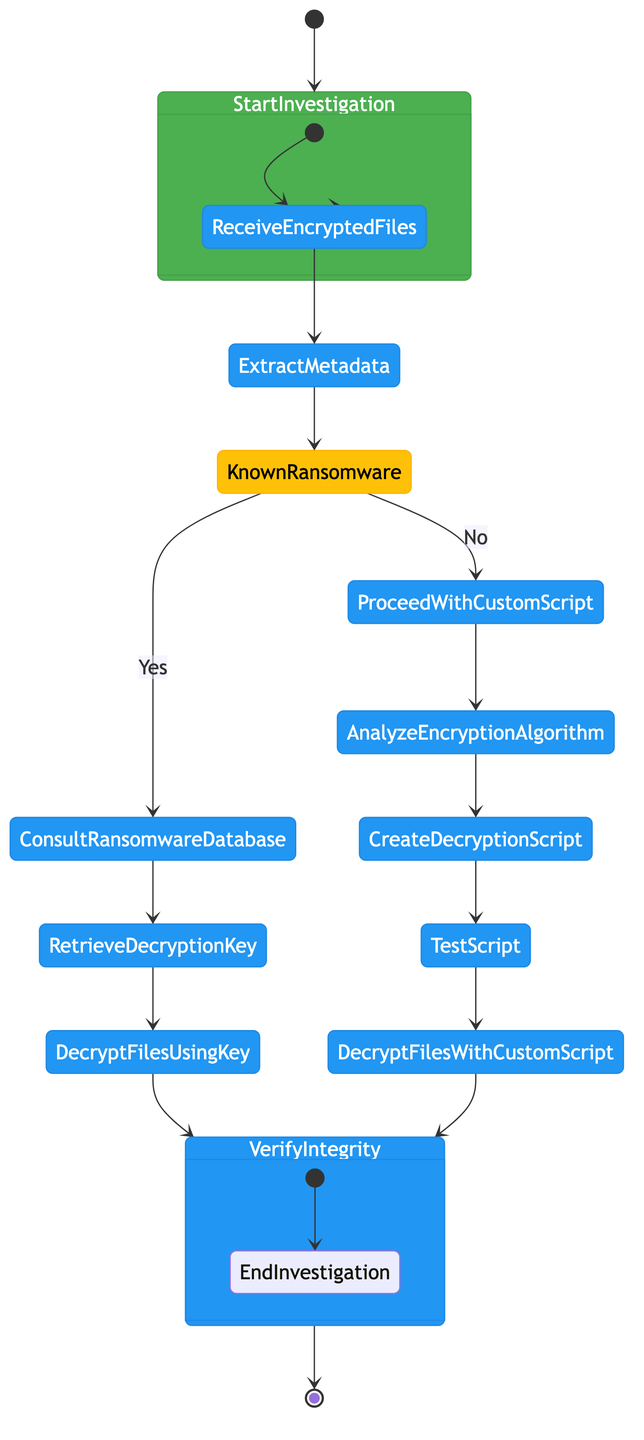What is the starting point of the investigation? The starting point is the "Start Investigation" node, which indicates where the flow of activities begins.
Answer: Start Investigation How many actions are present in the activity diagram? The diagram includes several action nodes: "Receive Encrypted Files," "Extract Metadata," "Consult Ransomware Database," "Retrieve Decryption Key," "Decrypt Files using Key," "Proceed with Custom Script," "Analyze Encryption Algorithm," "Create Decryption Script," "Test Script," "Decrypt Files with Custom Script," and "Verify Integrity." In total, there are 11 action nodes.
Answer: 11 What decision needs to be made after extracting metadata? The decision made after extracting metadata is whether the identified patterns match known ransomware, leading to the decision node "Known Ransomware?"
Answer: Known Ransomware? What do you do if the ransomware is known? If the ransomware is known, the next step after the "Known Ransomware?" decision is to "Consult Ransomware Database" and retrieve the decryption key.
Answer: Consult Ransomware Database If the ransomware is not recognized, what is the alternative action taken? If the ransomware is not recognized, the flow proceeds to "Proceed with Custom Script," wherein the investigation will develop custom decryption scripts instead of using a known decryption key.
Answer: Proceed with Custom Script Which activity occurs immediately after analyzing the encryption algorithm? After analyzing the encryption algorithm, the next step is to "Create Decryption Script," indicating that the investigator will now write a specific script to decrypt the files based on the analyzed encryption method.
Answer: Create Decryption Script What are the two possible ways to decrypt the files? The two possible ways to decrypt the files are: using the key obtained from the ransomware database and using the custom script developed by the investigator. This is determined at the "Known Ransomware?" decision point.
Answer: Using the key or using the custom script What is the final activity before ending the investigation? The final activity before ending the investigation is "Verify Integrity," which involves checking the integrity and completeness of the decrypted files to ensure they have been successfully unlocked.
Answer: Verify Integrity 